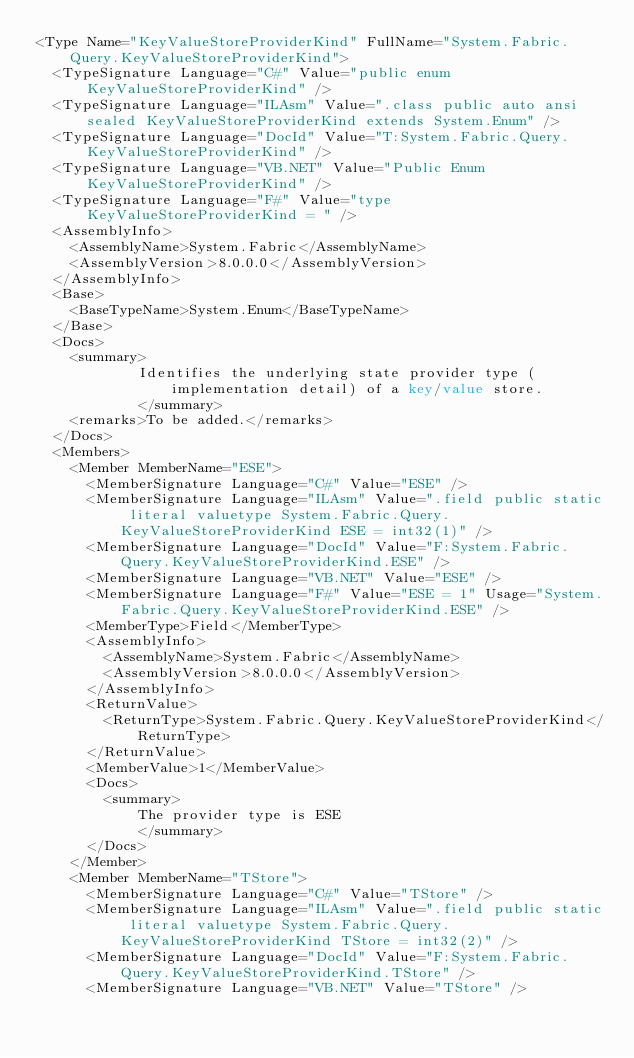Convert code to text. <code><loc_0><loc_0><loc_500><loc_500><_XML_><Type Name="KeyValueStoreProviderKind" FullName="System.Fabric.Query.KeyValueStoreProviderKind">
  <TypeSignature Language="C#" Value="public enum KeyValueStoreProviderKind" />
  <TypeSignature Language="ILAsm" Value=".class public auto ansi sealed KeyValueStoreProviderKind extends System.Enum" />
  <TypeSignature Language="DocId" Value="T:System.Fabric.Query.KeyValueStoreProviderKind" />
  <TypeSignature Language="VB.NET" Value="Public Enum KeyValueStoreProviderKind" />
  <TypeSignature Language="F#" Value="type KeyValueStoreProviderKind = " />
  <AssemblyInfo>
    <AssemblyName>System.Fabric</AssemblyName>
    <AssemblyVersion>8.0.0.0</AssemblyVersion>
  </AssemblyInfo>
  <Base>
    <BaseTypeName>System.Enum</BaseTypeName>
  </Base>
  <Docs>
    <summary>
            Identifies the underlying state provider type (implementation detail) of a key/value store.
            </summary>
    <remarks>To be added.</remarks>
  </Docs>
  <Members>
    <Member MemberName="ESE">
      <MemberSignature Language="C#" Value="ESE" />
      <MemberSignature Language="ILAsm" Value=".field public static literal valuetype System.Fabric.Query.KeyValueStoreProviderKind ESE = int32(1)" />
      <MemberSignature Language="DocId" Value="F:System.Fabric.Query.KeyValueStoreProviderKind.ESE" />
      <MemberSignature Language="VB.NET" Value="ESE" />
      <MemberSignature Language="F#" Value="ESE = 1" Usage="System.Fabric.Query.KeyValueStoreProviderKind.ESE" />
      <MemberType>Field</MemberType>
      <AssemblyInfo>
        <AssemblyName>System.Fabric</AssemblyName>
        <AssemblyVersion>8.0.0.0</AssemblyVersion>
      </AssemblyInfo>
      <ReturnValue>
        <ReturnType>System.Fabric.Query.KeyValueStoreProviderKind</ReturnType>
      </ReturnValue>
      <MemberValue>1</MemberValue>
      <Docs>
        <summary>
            The provider type is ESE
            </summary>
      </Docs>
    </Member>
    <Member MemberName="TStore">
      <MemberSignature Language="C#" Value="TStore" />
      <MemberSignature Language="ILAsm" Value=".field public static literal valuetype System.Fabric.Query.KeyValueStoreProviderKind TStore = int32(2)" />
      <MemberSignature Language="DocId" Value="F:System.Fabric.Query.KeyValueStoreProviderKind.TStore" />
      <MemberSignature Language="VB.NET" Value="TStore" /></code> 